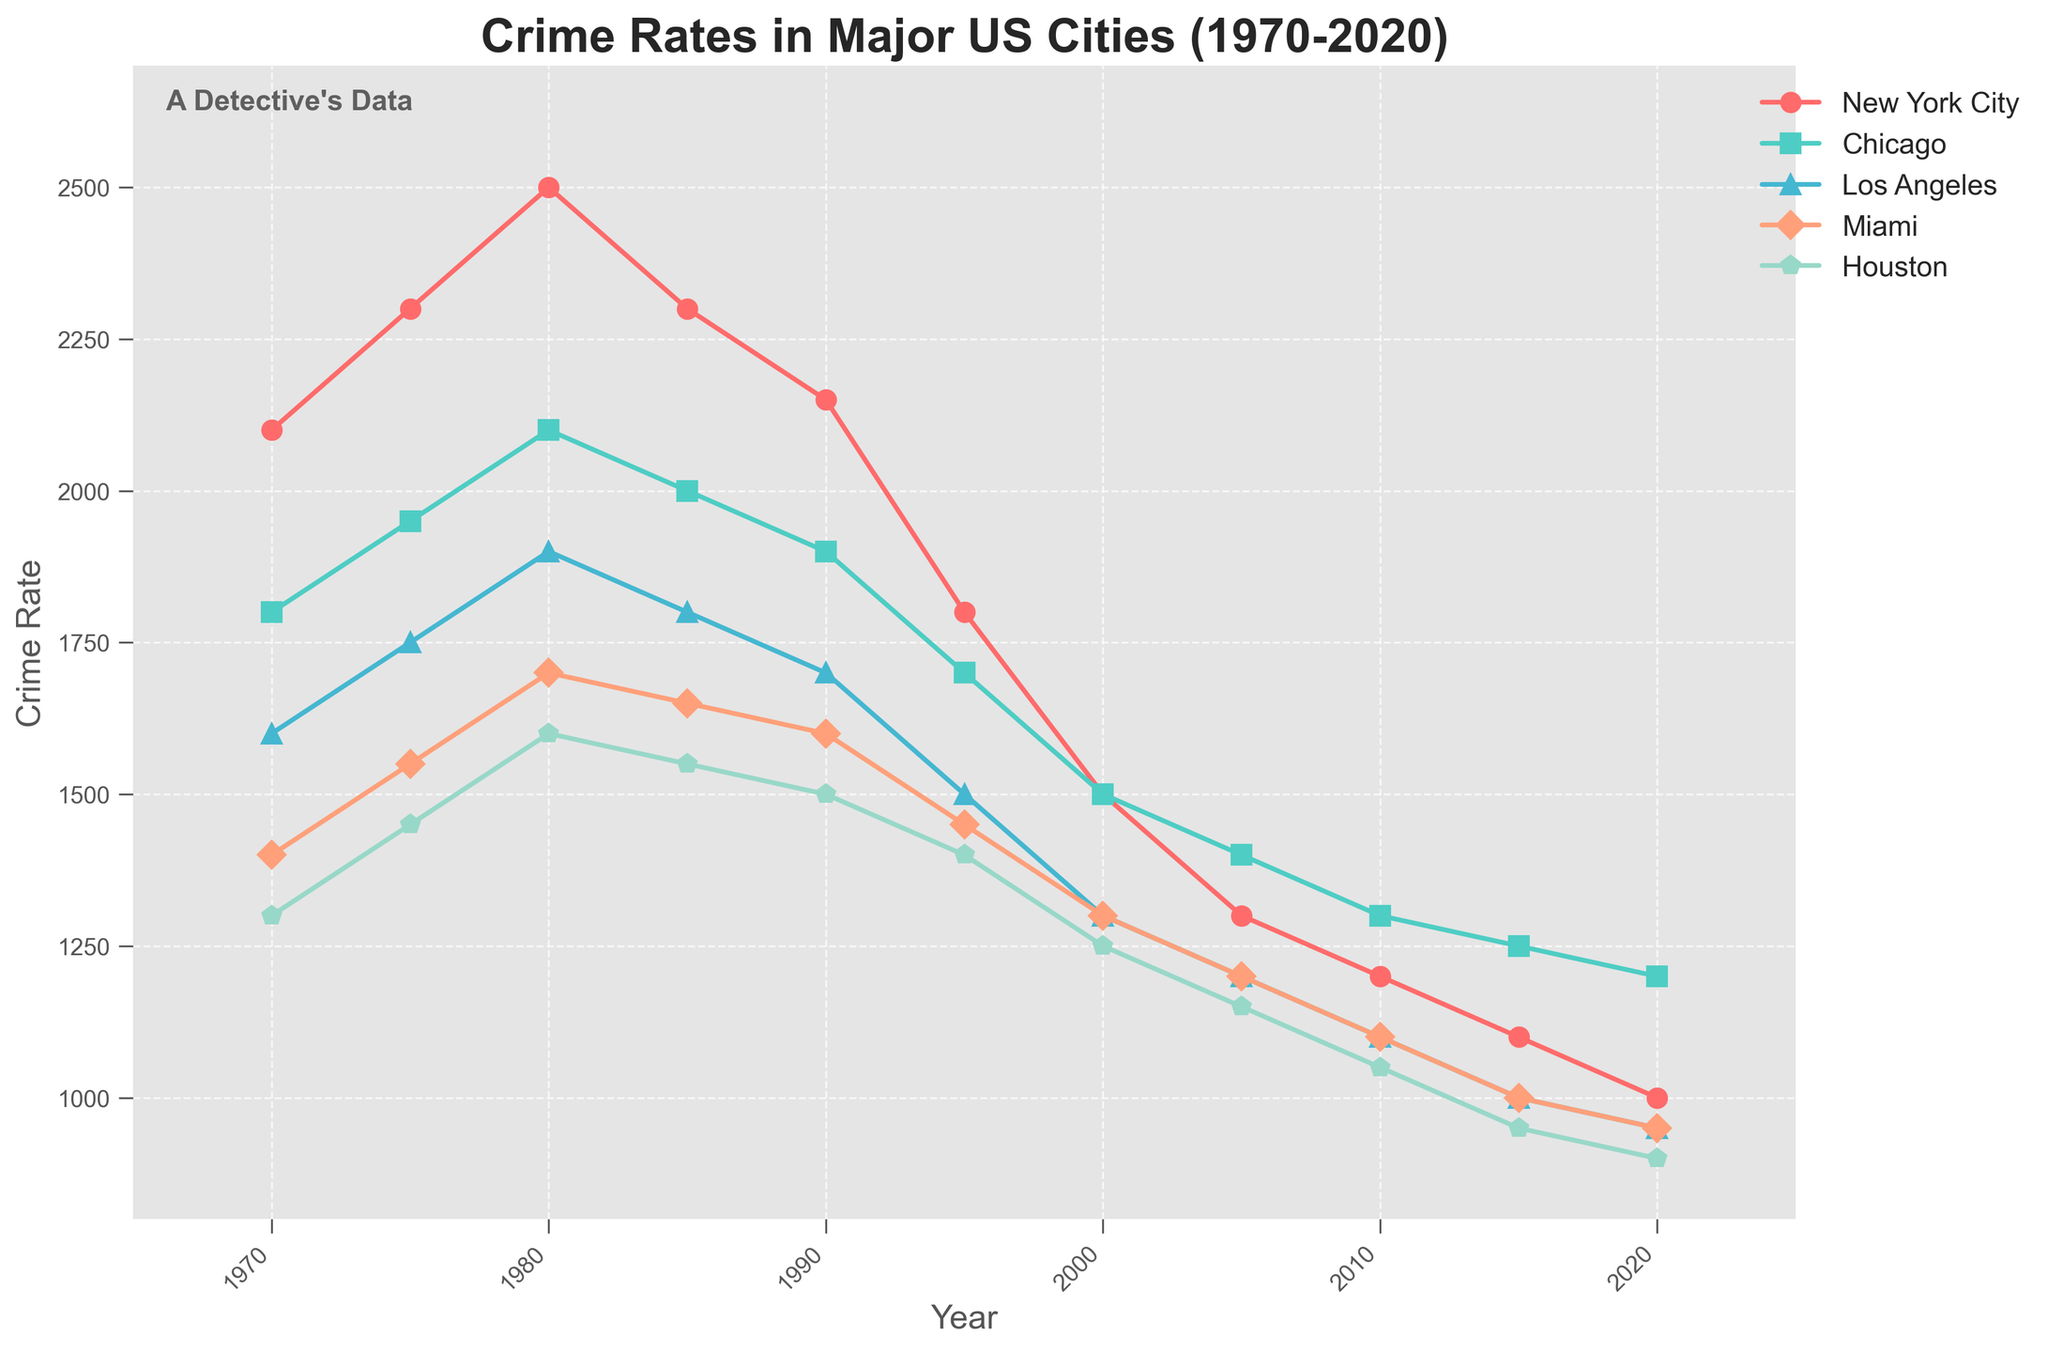Which city had the highest crime rate in 1980? From the figure, locate the year 1980 on the x-axis and observe the data point that corresponds to the highest value among the five cities.
Answer: New York City What is the average crime rate in Miami from 1970 to 2020? Identify the crime rates for Miami (1400, 1550, 1700, 1650, 1600, 1450, 1300, 1200, 1100, 1000, 950). Sum these values (16500) and divide by the number of data points (11) to get the average.
Answer: 1500 Which city showed the greatest decrease in crime rate from 1990 to 2000? Compare the crime rates in 1990 and 2000 for each city: New York City (2150-1500=650), Chicago (1900-1500=400), Los Angeles (1700-1300=400), Miami (1600-1300=300), and Houston (1500-1250=250).
Answer: New York City Did any city experience an increase in crime rate between 2010 and 2020? If so, which one? Examine the data points for each city in 2010 and 2020: New York City (1200 to 1000, decrease), Chicago (1300 to 1200, decrease), Los Angeles (1100 to 950, decrease), Miami (1100 to 950, decrease), and Houston (1050 to 900, decrease).
Answer: None Which city had the most consistent decline in crime rates from 1970 to 2020? New York City shows a consistent decline without significant fluctuations, while other cities have noticeable increases and decreases over the years.
Answer: New York City Compare the crime rate trends of Chicago and Los Angeles from 1970 to 2020. Which city had higher crime rates more frequently? Observe the crime rate lines for Chicago and Los Angeles. Chicago consistently had higher crime rates than Los Angeles in most years from 1970 to 2020.
Answer: Chicago What is the combined crime rate of all five cities in 1975 and 2020? Identify the crime rates for all cities in 1975 (2300+1950+1750+1550+1450=9000) and in 2020 (1000+1200+950+950+900=5000).
Answer: 9000 (1975) and 5000 (2020) Which city showed the smallest change in crime rate between 1980 and 2000? Compare the crime rates in 1980 and 2000 for each city: New York City (2500-1500=1000), Chicago (2100-1500=600), Los Angeles (1900-1300=600), Miami (1700-1300=400), and Houston (1600-1250=350).
Answer: Houston 